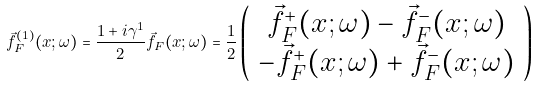<formula> <loc_0><loc_0><loc_500><loc_500>\vec { f } _ { F } ^ { ( 1 ) } ( x ; \omega ) = \frac { 1 + i \gamma ^ { 1 } } { 2 } \vec { f } _ { F } ( x ; \omega ) = \frac { 1 } { 2 } \left ( \begin{array} { c } \vec { f } _ { F } ^ { + } ( x ; \omega ) - \vec { f } _ { F } ^ { - } ( x ; \omega ) \\ - \vec { f } _ { F } ^ { + } ( x ; \omega ) + \vec { f } _ { F } ^ { - } ( x ; \omega ) \end{array} \right )</formula> 